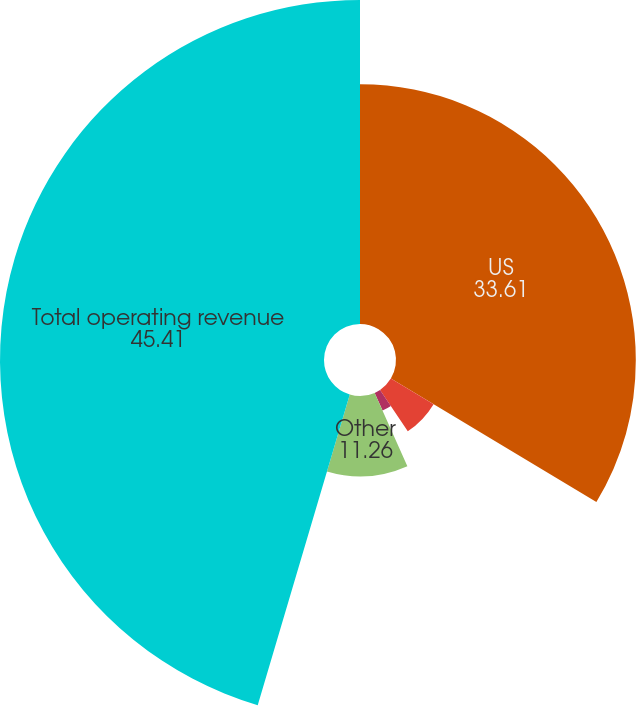Convert chart. <chart><loc_0><loc_0><loc_500><loc_500><pie_chart><fcel>US<fcel>UK<fcel>Canada<fcel>Other<fcel>Total operating revenue<nl><fcel>33.61%<fcel>6.99%<fcel>2.72%<fcel>11.26%<fcel>45.41%<nl></chart> 